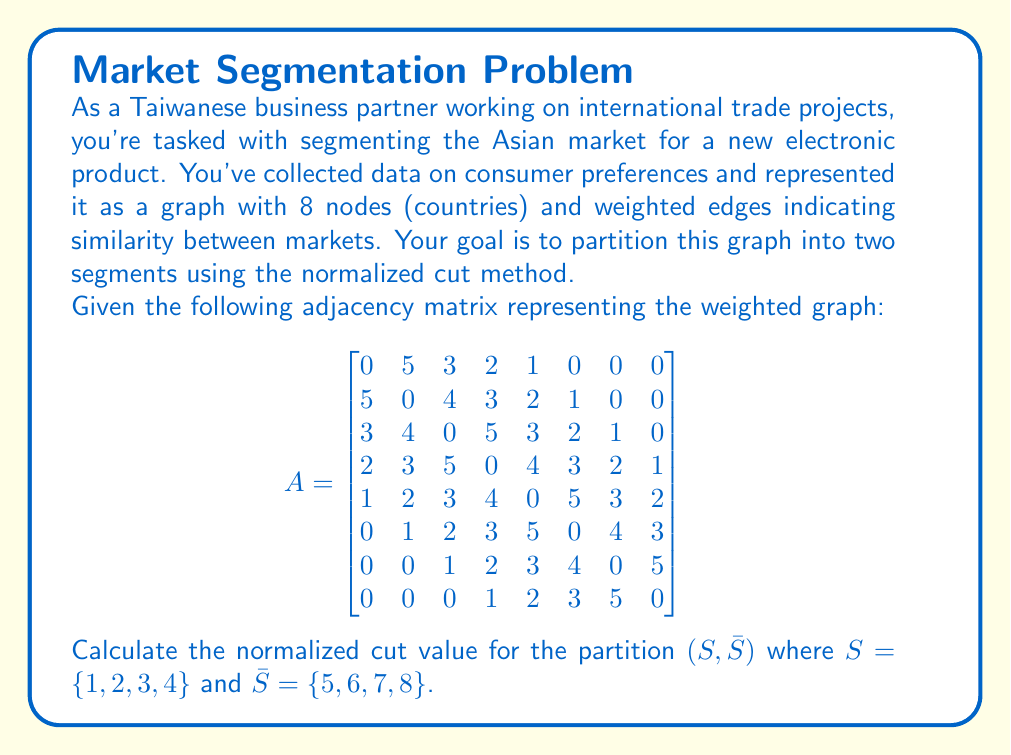Help me with this question. To calculate the normalized cut value, we'll follow these steps:

1) The normalized cut is defined as:

   $$Ncut(S, \bar{S}) = \frac{cut(S, \bar{S})}{vol(S)} + \frac{cut(S, \bar{S})}{vol(\bar{S})}$$

2) First, let's calculate $cut(S, \bar{S})$. This is the sum of weights of edges connecting $S$ and $\bar{S}$:
   
   $cut(S, \bar{S}) = A_{4,5} + A_{3,5} + A_{2,5} + A_{1,5} + A_{3,6} + A_{2,6} + A_{4,7} = 4 + 3 + 2 + 1 + 2 + 1 + 2 = 15$

3) Now, we need to calculate $vol(S)$ and $vol(\bar{S})$. The volume of a set is the sum of degrees of its nodes:

   $vol(S) = (5+3+2+1) + (5+4+3+2) + (3+4+5+3) + (2+3+5+4) = 11 + 14 + 15 + 14 = 54$
   
   $vol(\bar{S}) = (1+2+3+4+5) + (1+2+3+5+4) + (1+2+3+4+5) + (1+2+3+5) = 15 + 15 + 15 + 11 = 56$

4) Now we can substitute these values into the Ncut formula:

   $$Ncut(S, \bar{S}) = \frac{15}{54} + \frac{15}{56} = 0.2778 + 0.2679 = 0.5457$$

Therefore, the normalized cut value for this partition is approximately 0.5457.
Answer: 0.5457 